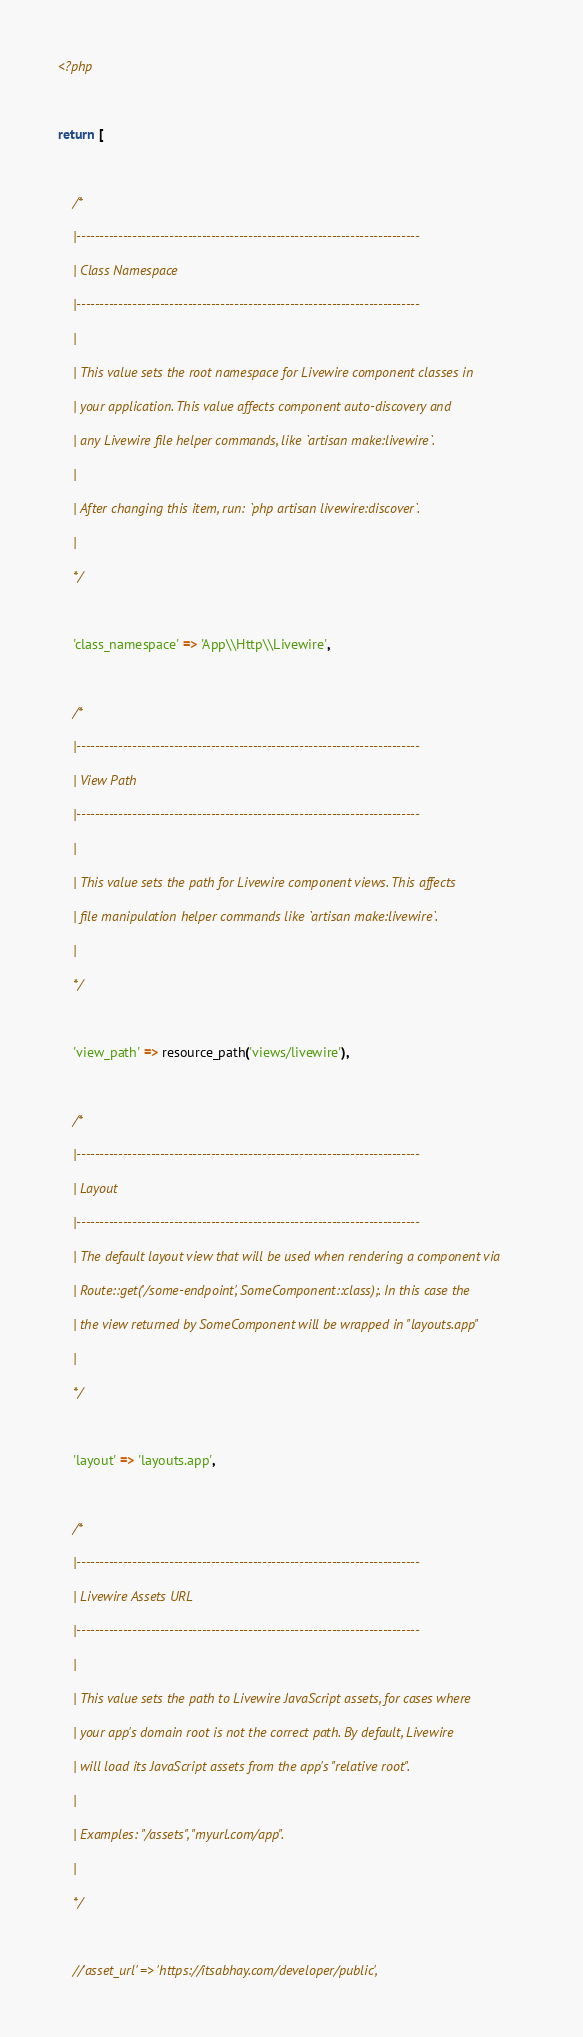<code> <loc_0><loc_0><loc_500><loc_500><_PHP_><?php

return [

    /*
    |--------------------------------------------------------------------------
    | Class Namespace
    |--------------------------------------------------------------------------
    |
    | This value sets the root namespace for Livewire component classes in
    | your application. This value affects component auto-discovery and
    | any Livewire file helper commands, like `artisan make:livewire`.
    |
    | After changing this item, run: `php artisan livewire:discover`.
    |
    */

    'class_namespace' => 'App\\Http\\Livewire',

    /*
    |--------------------------------------------------------------------------
    | View Path
    |--------------------------------------------------------------------------
    |
    | This value sets the path for Livewire component views. This affects
    | file manipulation helper commands like `artisan make:livewire`.
    |
    */

    'view_path' => resource_path('views/livewire'),

    /*
    |--------------------------------------------------------------------------
    | Layout
    |--------------------------------------------------------------------------
    | The default layout view that will be used when rendering a component via
    | Route::get('/some-endpoint', SomeComponent::class);. In this case the
    | the view returned by SomeComponent will be wrapped in "layouts.app"
    |
    */

    'layout' => 'layouts.app',

    /*
    |--------------------------------------------------------------------------
    | Livewire Assets URL
    |--------------------------------------------------------------------------
    |
    | This value sets the path to Livewire JavaScript assets, for cases where
    | your app's domain root is not the correct path. By default, Livewire
    | will load its JavaScript assets from the app's "relative root".
    |
    | Examples: "/assets", "myurl.com/app".
    |
    */

    //'asset_url' => 'https://itsabhay.com/developer/public',</code> 